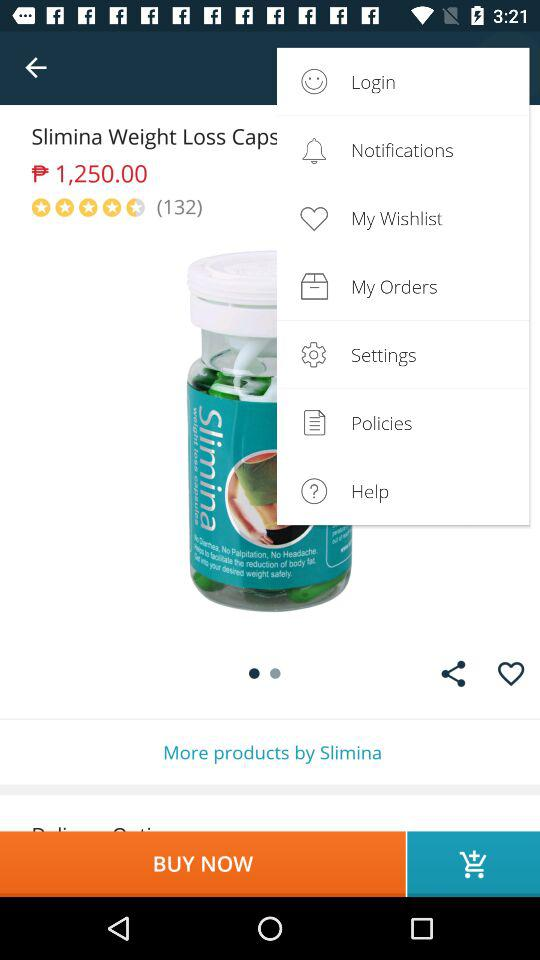How much is the price of the product?
Answer the question using a single word or phrase. $1,250.00 